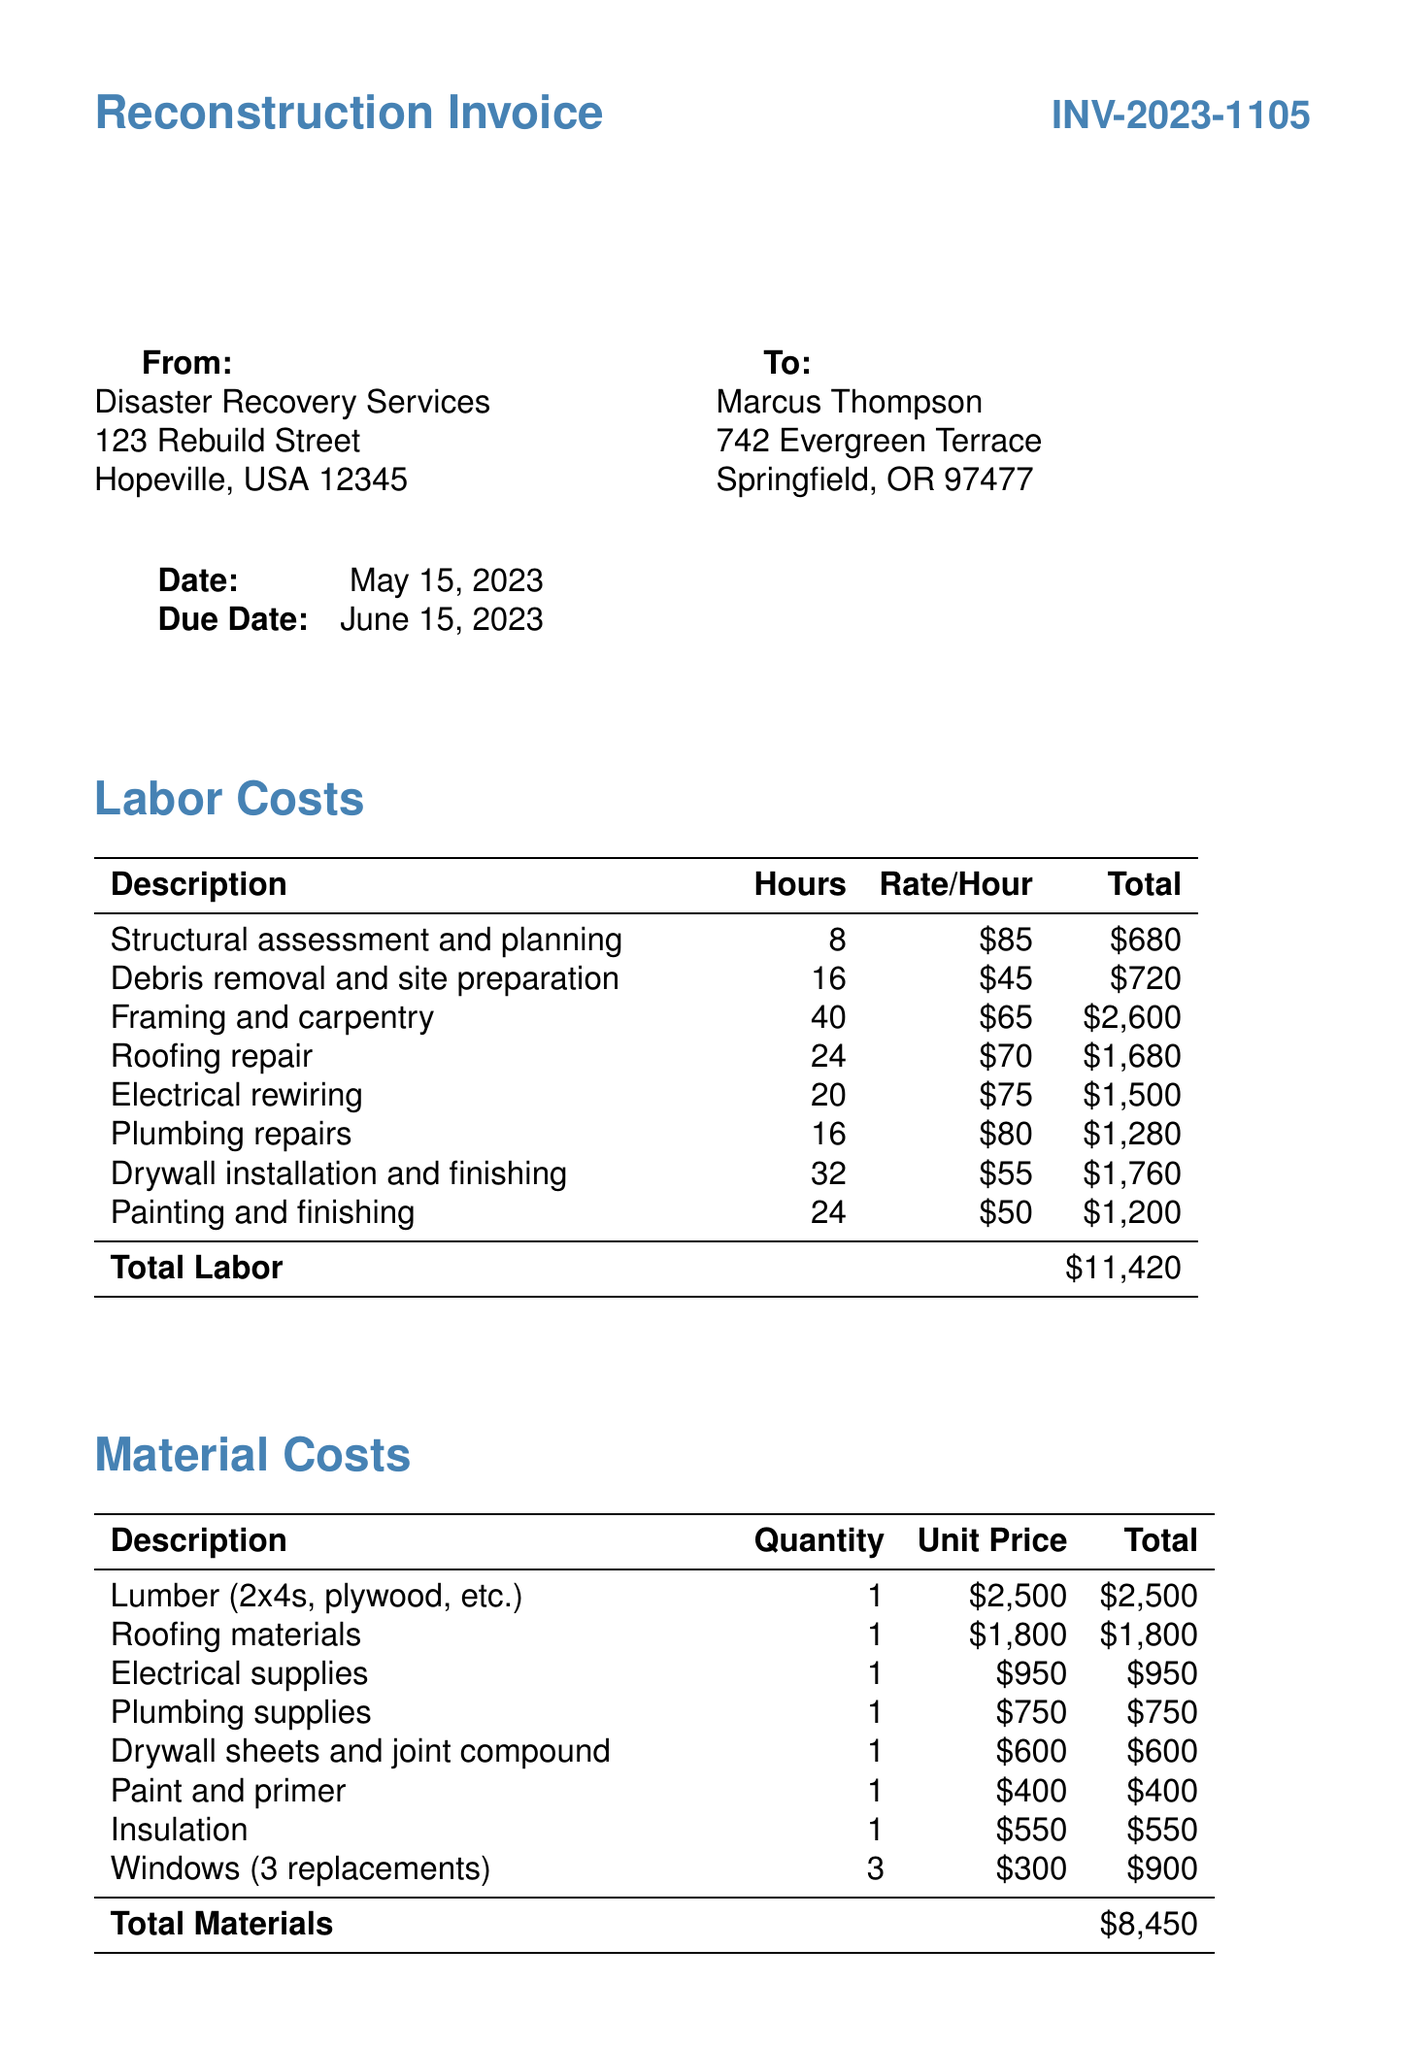What is the invoice number? The invoice number is explicitly stated in the document as "INV-2023-1105."
Answer: INV-2023-1105 What is the due date for the invoice? The due date can be found under the invoice details section, which is "June 15, 2023."
Answer: June 15, 2023 How much is charged for framing and carpentry? The total amount for framing and carpentry is mentioned in the labor costs section as "$2,600."
Answer: $2,600 What is the total amount for materials? The total for materials is provided in the materials costs section, which is "$8,450."
Answer: $8,450 What is the total additional fees? The total additional fees can be calculated from the additional fees section, which totals "$1,750."
Answer: $1,750 How many hours were spent on roofing repair? The document specifies that roofing repair took 24 hours, listed under labor costs.
Answer: 24 What is the subtotal of the invoice? The subtotal is explicitly stated in the final section as "$21,620."
Answer: $21,620 Who is the client? The client's name is provided prominently in the document as "Marcus Thompson."
Answer: Marcus Thompson What is Alex's relationship to the client? Alex refers to Marcus as someone with whom he shares a survivor experience, indicating a personal connection.
Answer: Fellow survivor 